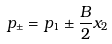<formula> <loc_0><loc_0><loc_500><loc_500>p _ { \pm } = p _ { 1 } \pm \frac { B } { 2 } x _ { 2 }</formula> 